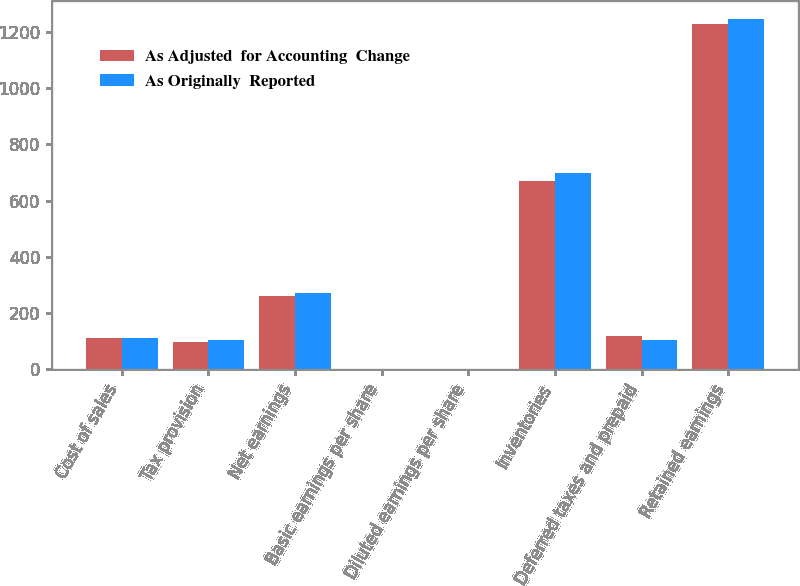<chart> <loc_0><loc_0><loc_500><loc_500><stacked_bar_chart><ecel><fcel>Cost of sales<fcel>Tax provision<fcel>Net earnings<fcel>Basic earnings per share<fcel>Diluted earnings per share<fcel>Inventories<fcel>Deferred taxes and prepaid<fcel>Retained earnings<nl><fcel>As Adjusted  for Accounting  Change<fcel>112.15<fcel>99.3<fcel>261.5<fcel>2.43<fcel>2.38<fcel>670.3<fcel>117.9<fcel>1227.9<nl><fcel>As Originally  Reported<fcel>112.15<fcel>106.2<fcel>272.1<fcel>2.52<fcel>2.48<fcel>699.9<fcel>106.4<fcel>1246<nl></chart> 